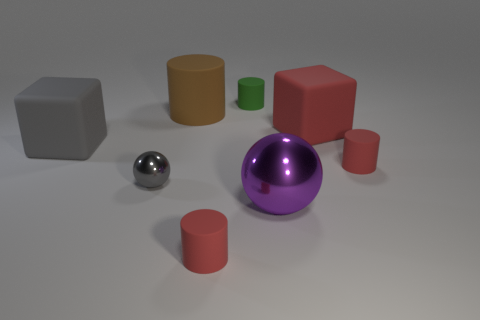Subtract all big cylinders. How many cylinders are left? 3 Subtract all gray spheres. How many spheres are left? 1 Add 2 big red metal cylinders. How many objects exist? 10 Subtract all red cubes. Subtract all red spheres. How many cubes are left? 1 Subtract all brown cubes. How many gray balls are left? 1 Subtract all red blocks. Subtract all large red objects. How many objects are left? 6 Add 5 rubber cylinders. How many rubber cylinders are left? 9 Add 4 matte blocks. How many matte blocks exist? 6 Subtract 0 blue blocks. How many objects are left? 8 Subtract all balls. How many objects are left? 6 